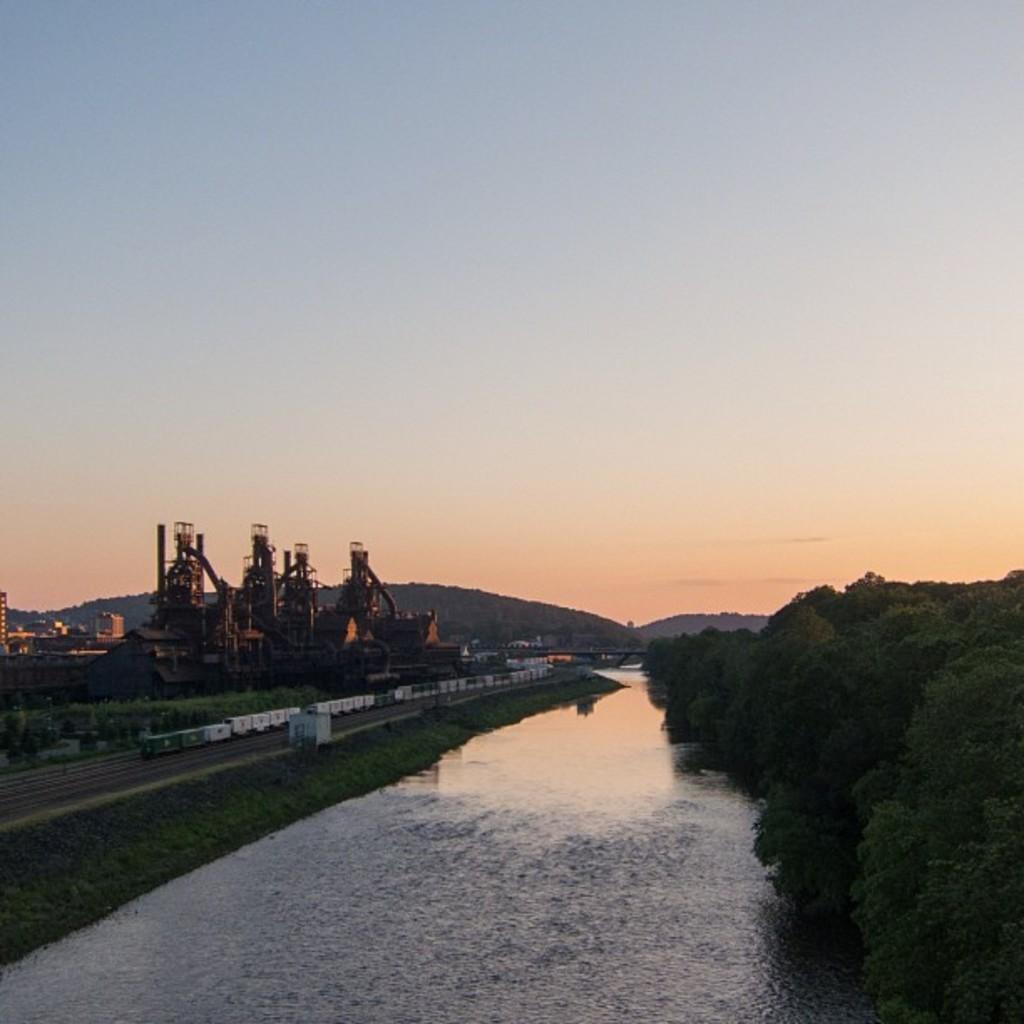How would you summarize this image in a sentence or two? This is an outside view. At the bottom there is a lake. On the right side there are many trees. On the left side, I can see a train and many buildings. At the top of the image I can see the sky. 